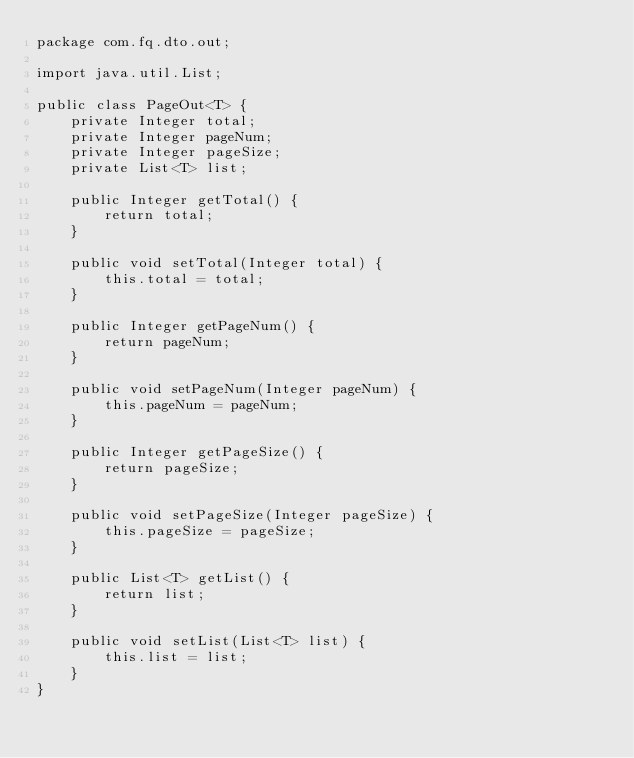Convert code to text. <code><loc_0><loc_0><loc_500><loc_500><_Java_>package com.fq.dto.out;

import java.util.List;

public class PageOut<T> {
    private Integer total;
    private Integer pageNum;
    private Integer pageSize;
    private List<T> list;

    public Integer getTotal() {
        return total;
    }

    public void setTotal(Integer total) {
        this.total = total;
    }

    public Integer getPageNum() {
        return pageNum;
    }

    public void setPageNum(Integer pageNum) {
        this.pageNum = pageNum;
    }

    public Integer getPageSize() {
        return pageSize;
    }

    public void setPageSize(Integer pageSize) {
        this.pageSize = pageSize;
    }

    public List<T> getList() {
        return list;
    }

    public void setList(List<T> list) {
        this.list = list;
    }
}
</code> 